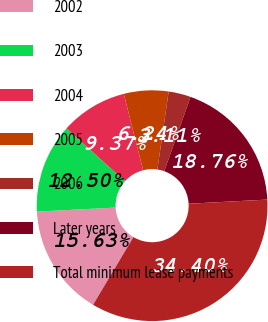Convert chart. <chart><loc_0><loc_0><loc_500><loc_500><pie_chart><fcel>2002<fcel>2003<fcel>2004<fcel>2005<fcel>2006<fcel>Later years<fcel>Total minimum lease payments<nl><fcel>15.63%<fcel>12.5%<fcel>9.37%<fcel>6.24%<fcel>3.11%<fcel>18.76%<fcel>34.4%<nl></chart> 